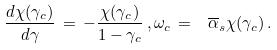Convert formula to latex. <formula><loc_0><loc_0><loc_500><loc_500>\frac { d \chi ( \gamma _ { c } ) } { d \gamma } \, = \, - \frac { \chi ( \gamma _ { c } ) } { 1 - \gamma _ { c } } \, , \omega _ { c } \, = \, \ \overline { \alpha } _ { s } \chi ( \gamma _ { c } ) \, .</formula> 